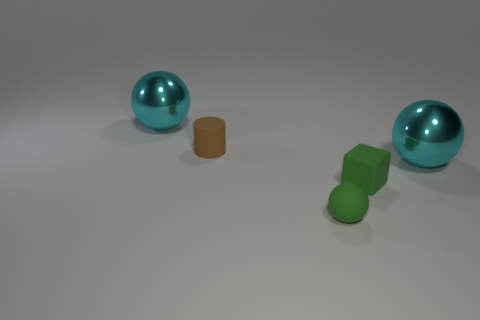There is a green sphere that is the same size as the cylinder; what is it made of?
Your answer should be compact. Rubber. The tiny rubber cylinder has what color?
Give a very brief answer. Brown. There is a tiny thing that is both in front of the matte cylinder and behind the matte ball; what material is it?
Make the answer very short. Rubber. There is a green object in front of the green rubber thing behind the green rubber ball; are there any big cyan metal balls behind it?
Give a very brief answer. Yes. There is a tiny green sphere; are there any large cyan balls to the left of it?
Offer a very short reply. Yes. What number of other things are there of the same shape as the tiny brown object?
Offer a terse response. 0. There is a sphere that is the same size as the cylinder; what color is it?
Your answer should be very brief. Green. Are there fewer matte cylinders that are right of the matte block than rubber objects that are on the right side of the brown cylinder?
Give a very brief answer. Yes. What number of small rubber cylinders are in front of the green object that is to the right of the matte ball on the right side of the brown rubber thing?
Offer a very short reply. 0. Are there fewer shiny objects in front of the tiny rubber cube than big yellow metal things?
Provide a succinct answer. No. 